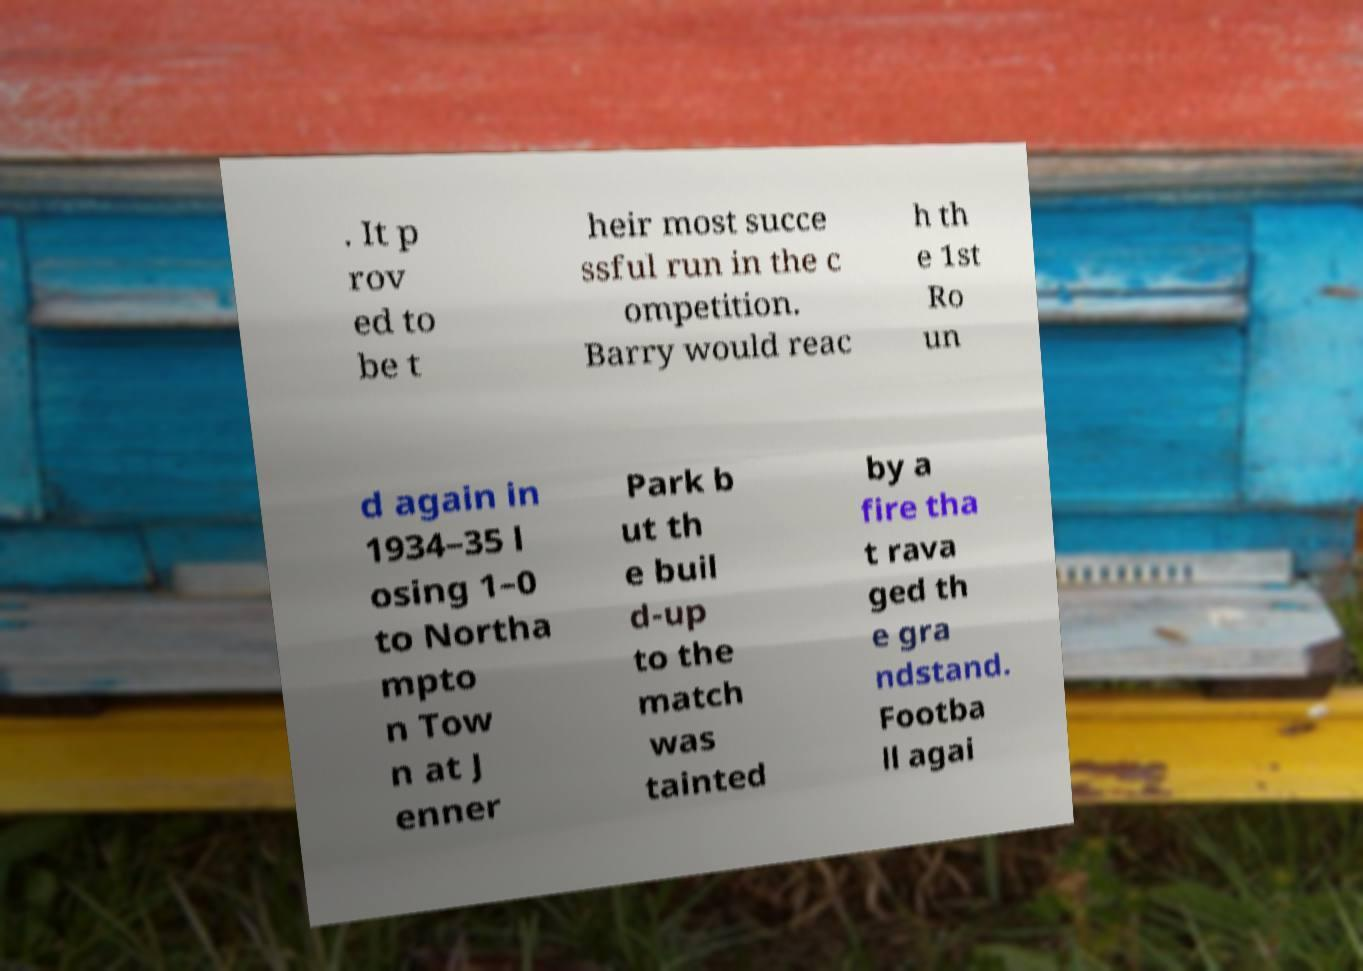Please read and relay the text visible in this image. What does it say? . It p rov ed to be t heir most succe ssful run in the c ompetition. Barry would reac h th e 1st Ro un d again in 1934–35 l osing 1–0 to Northa mpto n Tow n at J enner Park b ut th e buil d-up to the match was tainted by a fire tha t rava ged th e gra ndstand. Footba ll agai 